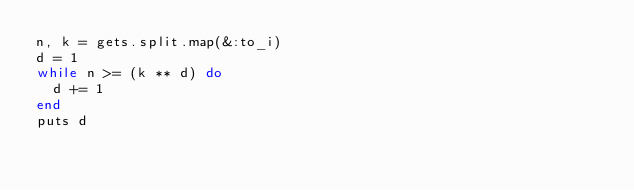Convert code to text. <code><loc_0><loc_0><loc_500><loc_500><_Ruby_>n, k = gets.split.map(&:to_i)
d = 1
while n >= (k ** d) do
  d += 1
end
puts d
</code> 